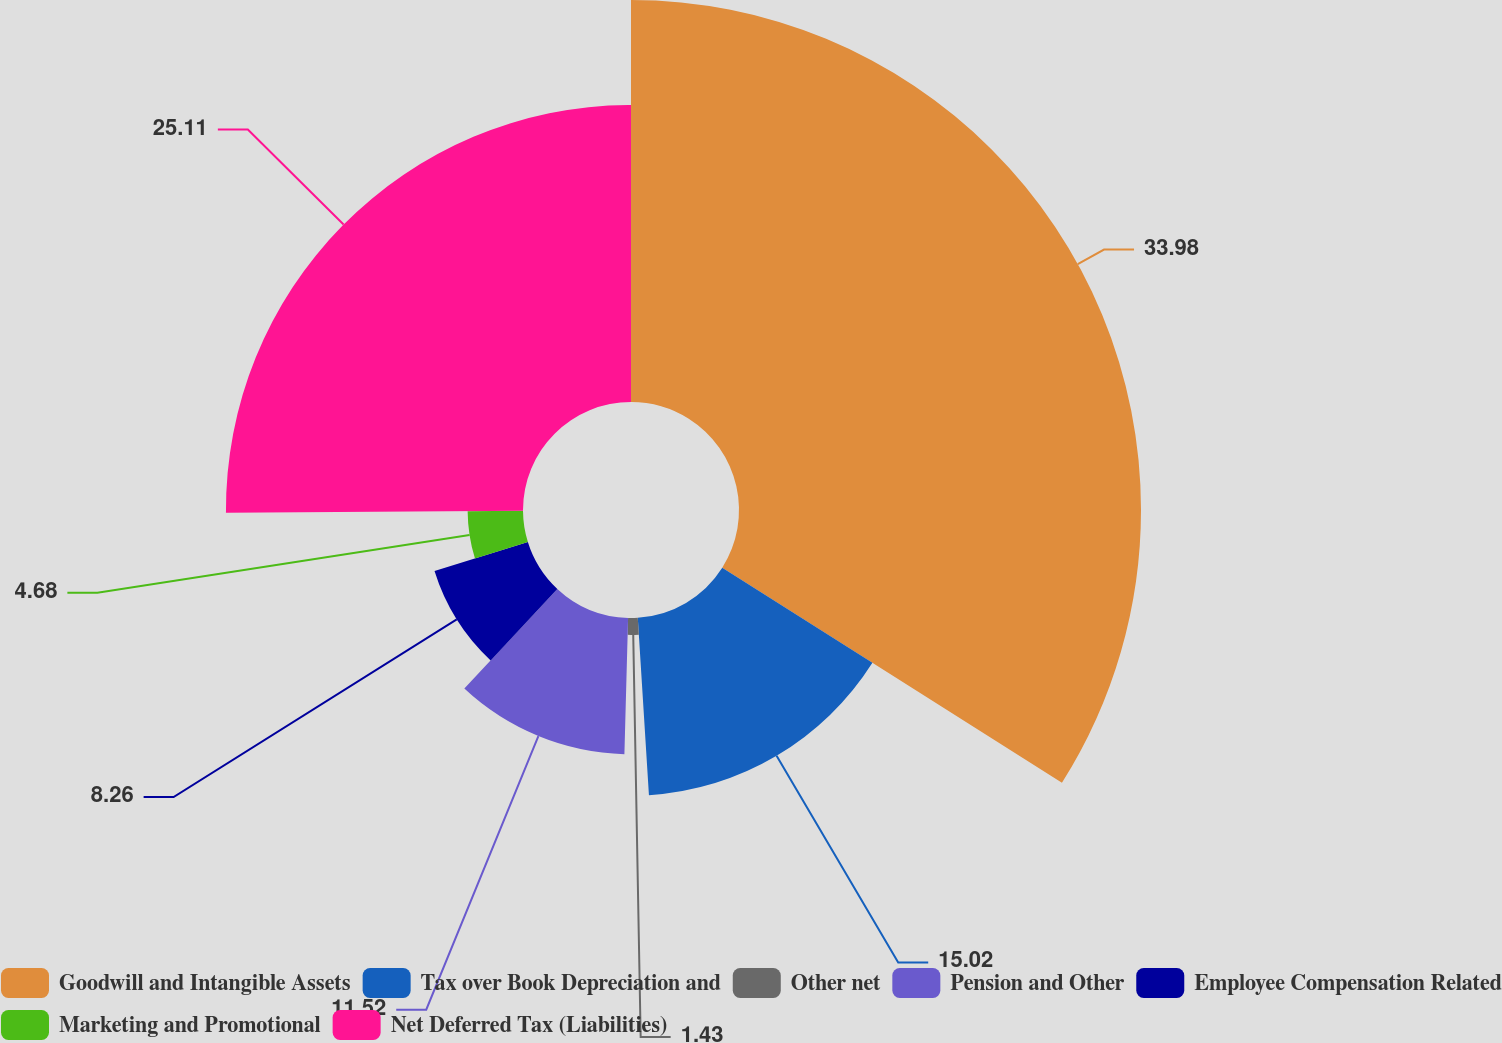<chart> <loc_0><loc_0><loc_500><loc_500><pie_chart><fcel>Goodwill and Intangible Assets<fcel>Tax over Book Depreciation and<fcel>Other net<fcel>Pension and Other<fcel>Employee Compensation Related<fcel>Marketing and Promotional<fcel>Net Deferred Tax (Liabilities)<nl><fcel>33.98%<fcel>15.02%<fcel>1.43%<fcel>11.52%<fcel>8.26%<fcel>4.68%<fcel>25.11%<nl></chart> 